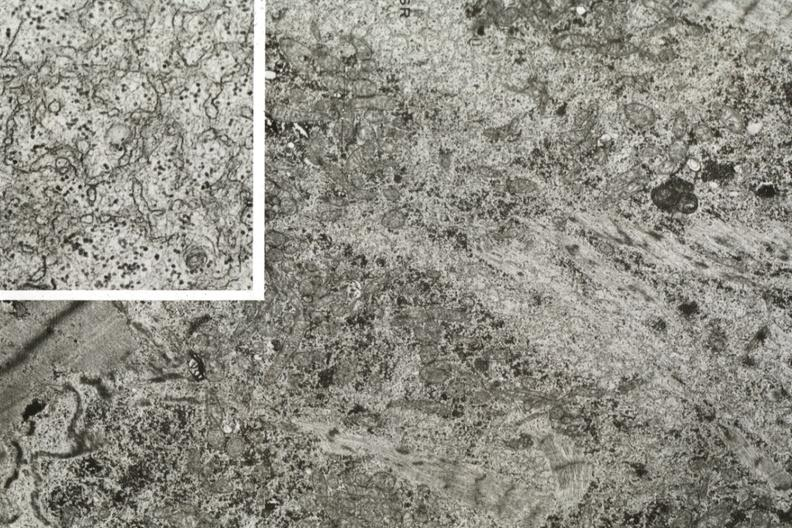s cardiovascular present?
Answer the question using a single word or phrase. Yes 